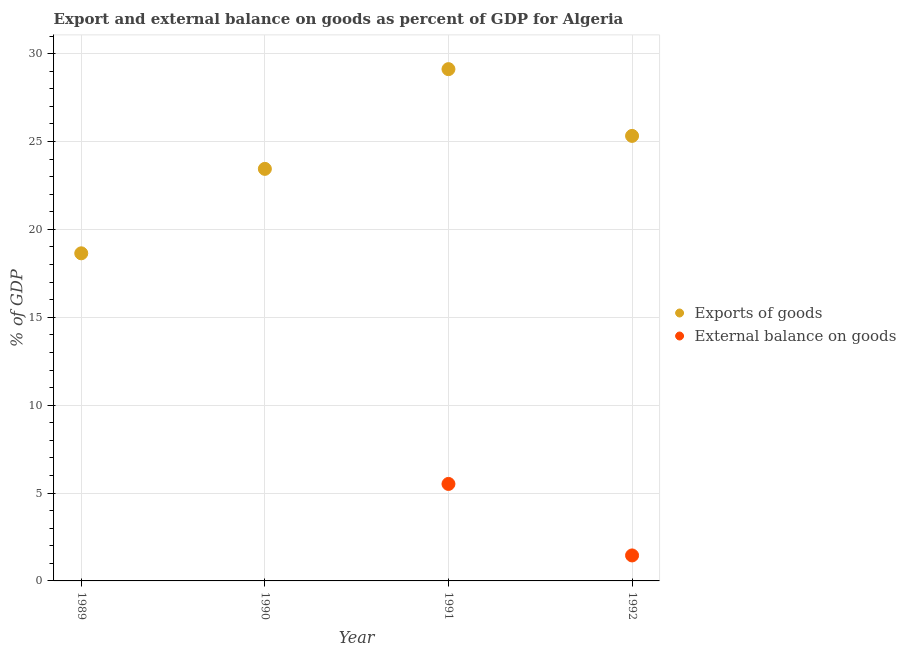How many different coloured dotlines are there?
Provide a short and direct response. 2. What is the export of goods as percentage of gdp in 1992?
Offer a terse response. 25.32. Across all years, what is the maximum external balance on goods as percentage of gdp?
Make the answer very short. 5.52. Across all years, what is the minimum export of goods as percentage of gdp?
Your answer should be very brief. 18.64. In which year was the export of goods as percentage of gdp maximum?
Your answer should be compact. 1991. What is the total export of goods as percentage of gdp in the graph?
Provide a succinct answer. 96.52. What is the difference between the export of goods as percentage of gdp in 1991 and that in 1992?
Offer a terse response. 3.8. What is the difference between the external balance on goods as percentage of gdp in 1989 and the export of goods as percentage of gdp in 1991?
Offer a very short reply. -29.12. What is the average external balance on goods as percentage of gdp per year?
Ensure brevity in your answer.  1.74. In the year 1991, what is the difference between the external balance on goods as percentage of gdp and export of goods as percentage of gdp?
Your response must be concise. -23.6. What is the ratio of the external balance on goods as percentage of gdp in 1991 to that in 1992?
Your answer should be compact. 3.81. Is the export of goods as percentage of gdp in 1991 less than that in 1992?
Your response must be concise. No. Is the difference between the export of goods as percentage of gdp in 1991 and 1992 greater than the difference between the external balance on goods as percentage of gdp in 1991 and 1992?
Your answer should be very brief. No. What is the difference between the highest and the second highest export of goods as percentage of gdp?
Offer a terse response. 3.8. What is the difference between the highest and the lowest export of goods as percentage of gdp?
Offer a very short reply. 10.48. In how many years, is the external balance on goods as percentage of gdp greater than the average external balance on goods as percentage of gdp taken over all years?
Your answer should be very brief. 1. Does the export of goods as percentage of gdp monotonically increase over the years?
Offer a very short reply. No. How many dotlines are there?
Your response must be concise. 2. Are the values on the major ticks of Y-axis written in scientific E-notation?
Your answer should be very brief. No. Where does the legend appear in the graph?
Offer a very short reply. Center right. How many legend labels are there?
Offer a terse response. 2. How are the legend labels stacked?
Offer a terse response. Vertical. What is the title of the graph?
Make the answer very short. Export and external balance on goods as percent of GDP for Algeria. What is the label or title of the Y-axis?
Offer a very short reply. % of GDP. What is the % of GDP of Exports of goods in 1989?
Make the answer very short. 18.64. What is the % of GDP of External balance on goods in 1989?
Your answer should be compact. 0. What is the % of GDP of Exports of goods in 1990?
Provide a succinct answer. 23.44. What is the % of GDP in Exports of goods in 1991?
Keep it short and to the point. 29.12. What is the % of GDP of External balance on goods in 1991?
Your answer should be compact. 5.52. What is the % of GDP of Exports of goods in 1992?
Provide a succinct answer. 25.32. What is the % of GDP in External balance on goods in 1992?
Give a very brief answer. 1.45. Across all years, what is the maximum % of GDP in Exports of goods?
Give a very brief answer. 29.12. Across all years, what is the maximum % of GDP of External balance on goods?
Keep it short and to the point. 5.52. Across all years, what is the minimum % of GDP in Exports of goods?
Give a very brief answer. 18.64. Across all years, what is the minimum % of GDP of External balance on goods?
Keep it short and to the point. 0. What is the total % of GDP in Exports of goods in the graph?
Keep it short and to the point. 96.52. What is the total % of GDP in External balance on goods in the graph?
Ensure brevity in your answer.  6.97. What is the difference between the % of GDP of Exports of goods in 1989 and that in 1990?
Offer a very short reply. -4.8. What is the difference between the % of GDP in Exports of goods in 1989 and that in 1991?
Offer a very short reply. -10.48. What is the difference between the % of GDP of Exports of goods in 1989 and that in 1992?
Provide a succinct answer. -6.68. What is the difference between the % of GDP of Exports of goods in 1990 and that in 1991?
Give a very brief answer. -5.67. What is the difference between the % of GDP in Exports of goods in 1990 and that in 1992?
Your response must be concise. -1.88. What is the difference between the % of GDP of Exports of goods in 1991 and that in 1992?
Ensure brevity in your answer.  3.8. What is the difference between the % of GDP in External balance on goods in 1991 and that in 1992?
Your answer should be very brief. 4.07. What is the difference between the % of GDP in Exports of goods in 1989 and the % of GDP in External balance on goods in 1991?
Ensure brevity in your answer.  13.12. What is the difference between the % of GDP in Exports of goods in 1989 and the % of GDP in External balance on goods in 1992?
Your answer should be compact. 17.19. What is the difference between the % of GDP in Exports of goods in 1990 and the % of GDP in External balance on goods in 1991?
Make the answer very short. 17.93. What is the difference between the % of GDP in Exports of goods in 1990 and the % of GDP in External balance on goods in 1992?
Provide a short and direct response. 21.99. What is the difference between the % of GDP of Exports of goods in 1991 and the % of GDP of External balance on goods in 1992?
Offer a very short reply. 27.67. What is the average % of GDP in Exports of goods per year?
Your answer should be compact. 24.13. What is the average % of GDP of External balance on goods per year?
Keep it short and to the point. 1.74. In the year 1991, what is the difference between the % of GDP in Exports of goods and % of GDP in External balance on goods?
Your answer should be compact. 23.6. In the year 1992, what is the difference between the % of GDP in Exports of goods and % of GDP in External balance on goods?
Your answer should be very brief. 23.87. What is the ratio of the % of GDP of Exports of goods in 1989 to that in 1990?
Give a very brief answer. 0.8. What is the ratio of the % of GDP in Exports of goods in 1989 to that in 1991?
Make the answer very short. 0.64. What is the ratio of the % of GDP of Exports of goods in 1989 to that in 1992?
Make the answer very short. 0.74. What is the ratio of the % of GDP of Exports of goods in 1990 to that in 1991?
Provide a short and direct response. 0.81. What is the ratio of the % of GDP of Exports of goods in 1990 to that in 1992?
Your answer should be compact. 0.93. What is the ratio of the % of GDP of Exports of goods in 1991 to that in 1992?
Keep it short and to the point. 1.15. What is the ratio of the % of GDP in External balance on goods in 1991 to that in 1992?
Your answer should be very brief. 3.81. What is the difference between the highest and the second highest % of GDP of Exports of goods?
Your answer should be very brief. 3.8. What is the difference between the highest and the lowest % of GDP in Exports of goods?
Provide a short and direct response. 10.48. What is the difference between the highest and the lowest % of GDP of External balance on goods?
Your answer should be very brief. 5.52. 